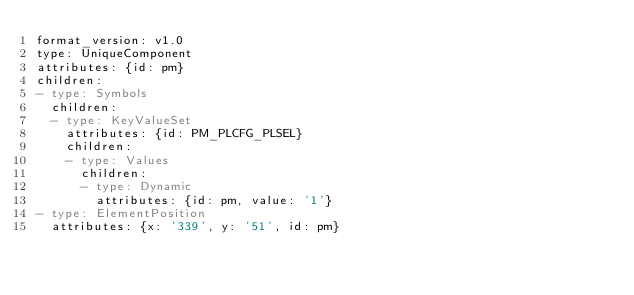<code> <loc_0><loc_0><loc_500><loc_500><_YAML_>format_version: v1.0
type: UniqueComponent
attributes: {id: pm}
children:
- type: Symbols
  children:
  - type: KeyValueSet
    attributes: {id: PM_PLCFG_PLSEL}
    children:
    - type: Values
      children:
      - type: Dynamic
        attributes: {id: pm, value: '1'}
- type: ElementPosition
  attributes: {x: '339', y: '51', id: pm}
</code> 